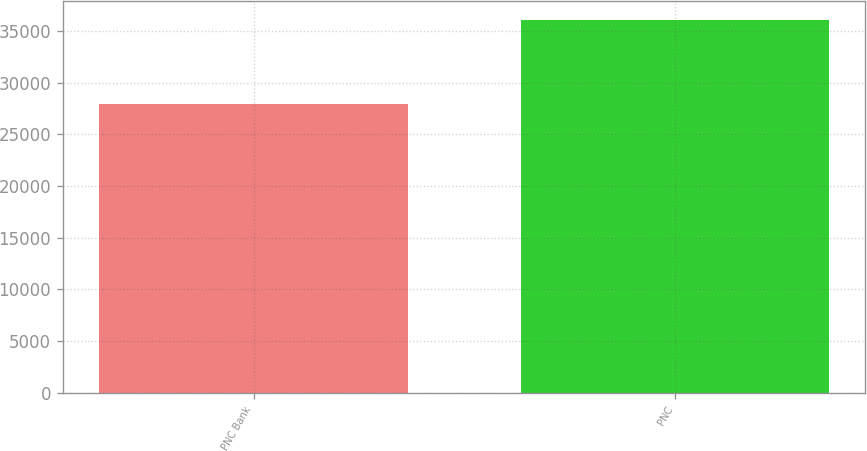Convert chart to OTSL. <chart><loc_0><loc_0><loc_500><loc_500><bar_chart><fcel>PNC Bank<fcel>PNC<nl><fcel>27896<fcel>36101<nl></chart> 